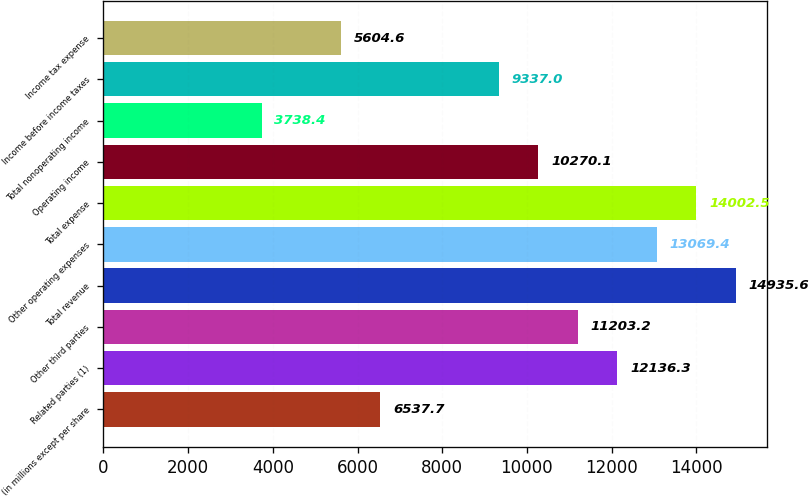<chart> <loc_0><loc_0><loc_500><loc_500><bar_chart><fcel>(in millions except per share<fcel>Related parties (1)<fcel>Other third parties<fcel>Total revenue<fcel>Other operating expenses<fcel>Total expense<fcel>Operating income<fcel>Total nonoperating income<fcel>Income before income taxes<fcel>Income tax expense<nl><fcel>6537.7<fcel>12136.3<fcel>11203.2<fcel>14935.6<fcel>13069.4<fcel>14002.5<fcel>10270.1<fcel>3738.4<fcel>9337<fcel>5604.6<nl></chart> 